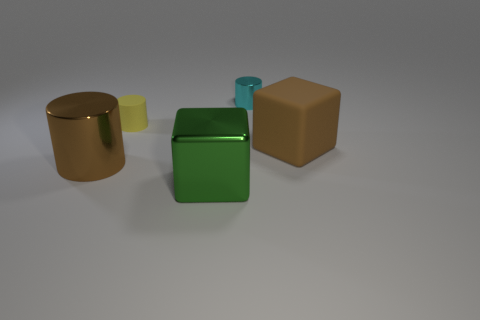Is the number of small yellow matte objects on the left side of the small metallic cylinder the same as the number of big brown metal cylinders?
Make the answer very short. Yes. How many purple metal cylinders are there?
Offer a very short reply. 0. There is a shiny object that is to the right of the tiny yellow rubber thing and in front of the small rubber thing; what is its shape?
Your answer should be compact. Cube. There is a large thing that is right of the small metallic object; is its color the same as the small thing that is on the right side of the green thing?
Make the answer very short. No. There is a metal thing that is the same color as the big rubber thing; what size is it?
Provide a short and direct response. Large. Is there a big thing that has the same material as the brown cylinder?
Ensure brevity in your answer.  Yes. Are there an equal number of tiny cylinders that are to the left of the big metal cylinder and yellow things that are right of the small cyan cylinder?
Keep it short and to the point. Yes. There is a brown thing that is to the left of the big brown rubber block; what size is it?
Give a very brief answer. Large. The large thing that is behind the cylinder in front of the tiny yellow matte object is made of what material?
Make the answer very short. Rubber. There is a large brown object that is right of the big cube in front of the large rubber object; what number of small yellow things are right of it?
Your answer should be very brief. 0. 